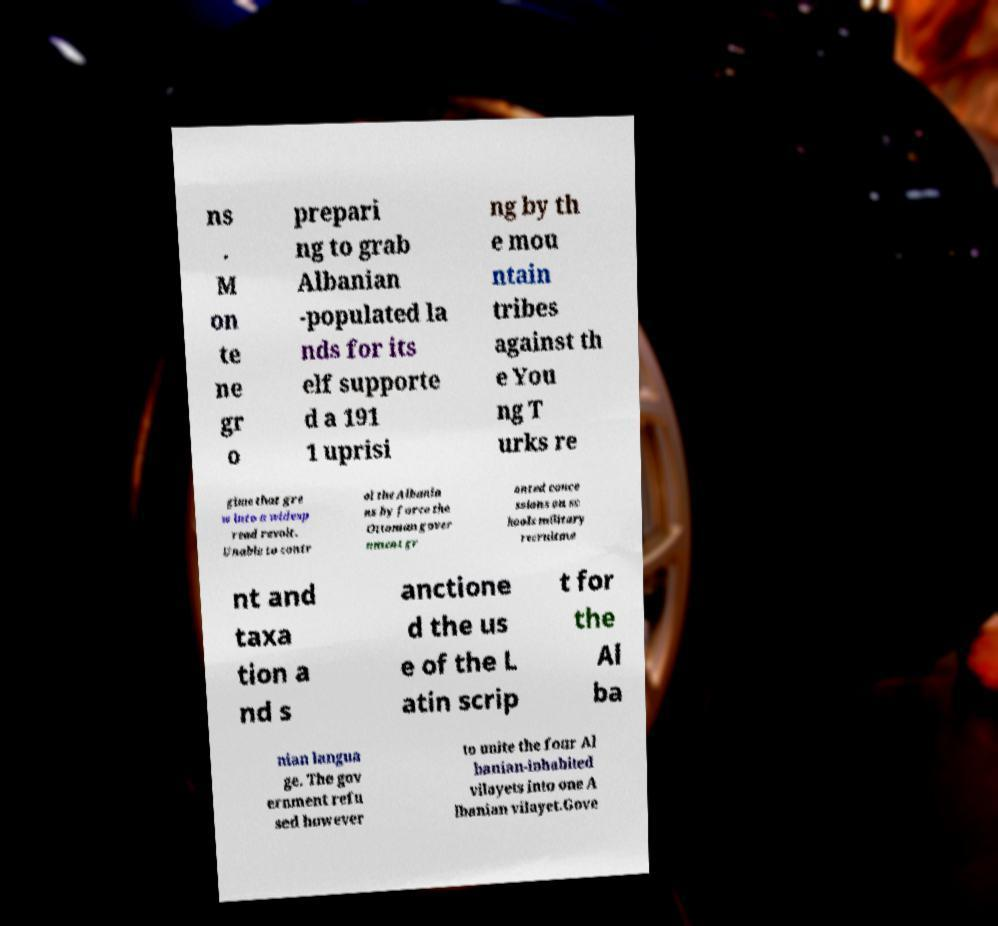Could you assist in decoding the text presented in this image and type it out clearly? ns . M on te ne gr o prepari ng to grab Albanian -populated la nds for its elf supporte d a 191 1 uprisi ng by th e mou ntain tribes against th e You ng T urks re gime that gre w into a widesp read revolt. Unable to contr ol the Albania ns by force the Ottoman gover nment gr anted conce ssions on sc hools military recruitme nt and taxa tion a nd s anctione d the us e of the L atin scrip t for the Al ba nian langua ge. The gov ernment refu sed however to unite the four Al banian-inhabited vilayets into one A lbanian vilayet.Gove 